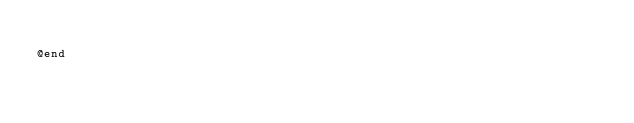<code> <loc_0><loc_0><loc_500><loc_500><_C_>
@end
</code> 